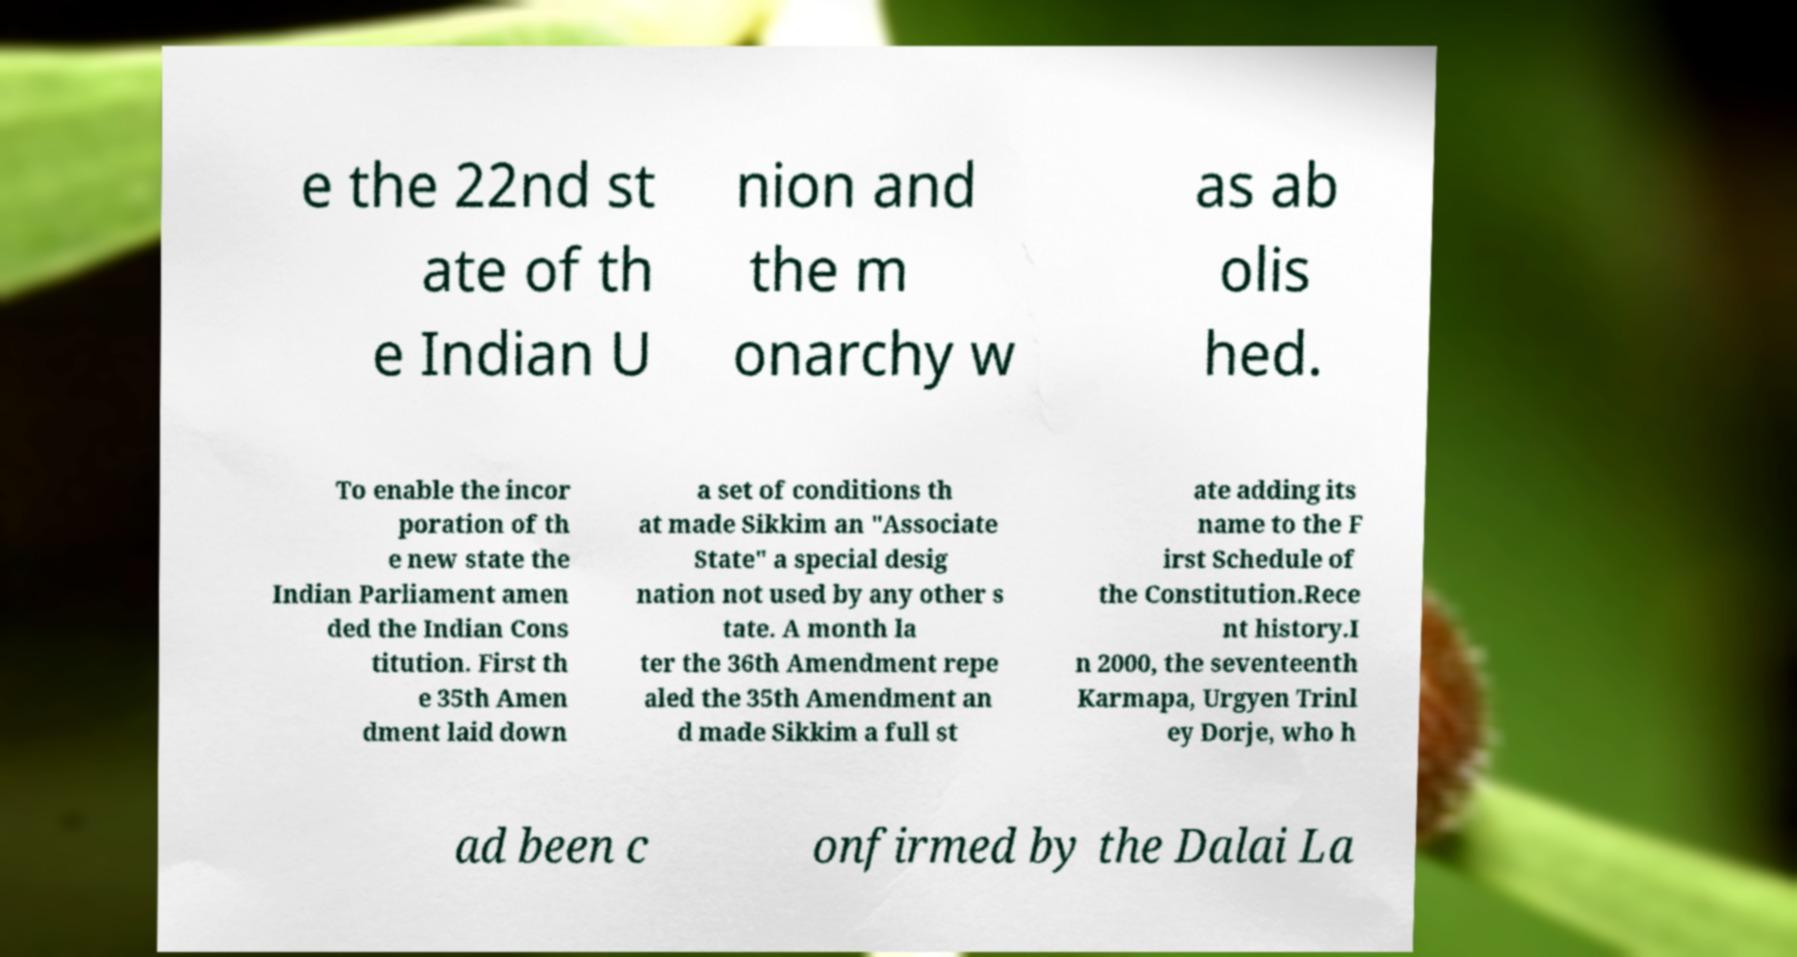There's text embedded in this image that I need extracted. Can you transcribe it verbatim? e the 22nd st ate of th e Indian U nion and the m onarchy w as ab olis hed. To enable the incor poration of th e new state the Indian Parliament amen ded the Indian Cons titution. First th e 35th Amen dment laid down a set of conditions th at made Sikkim an "Associate State" a special desig nation not used by any other s tate. A month la ter the 36th Amendment repe aled the 35th Amendment an d made Sikkim a full st ate adding its name to the F irst Schedule of the Constitution.Rece nt history.I n 2000, the seventeenth Karmapa, Urgyen Trinl ey Dorje, who h ad been c onfirmed by the Dalai La 